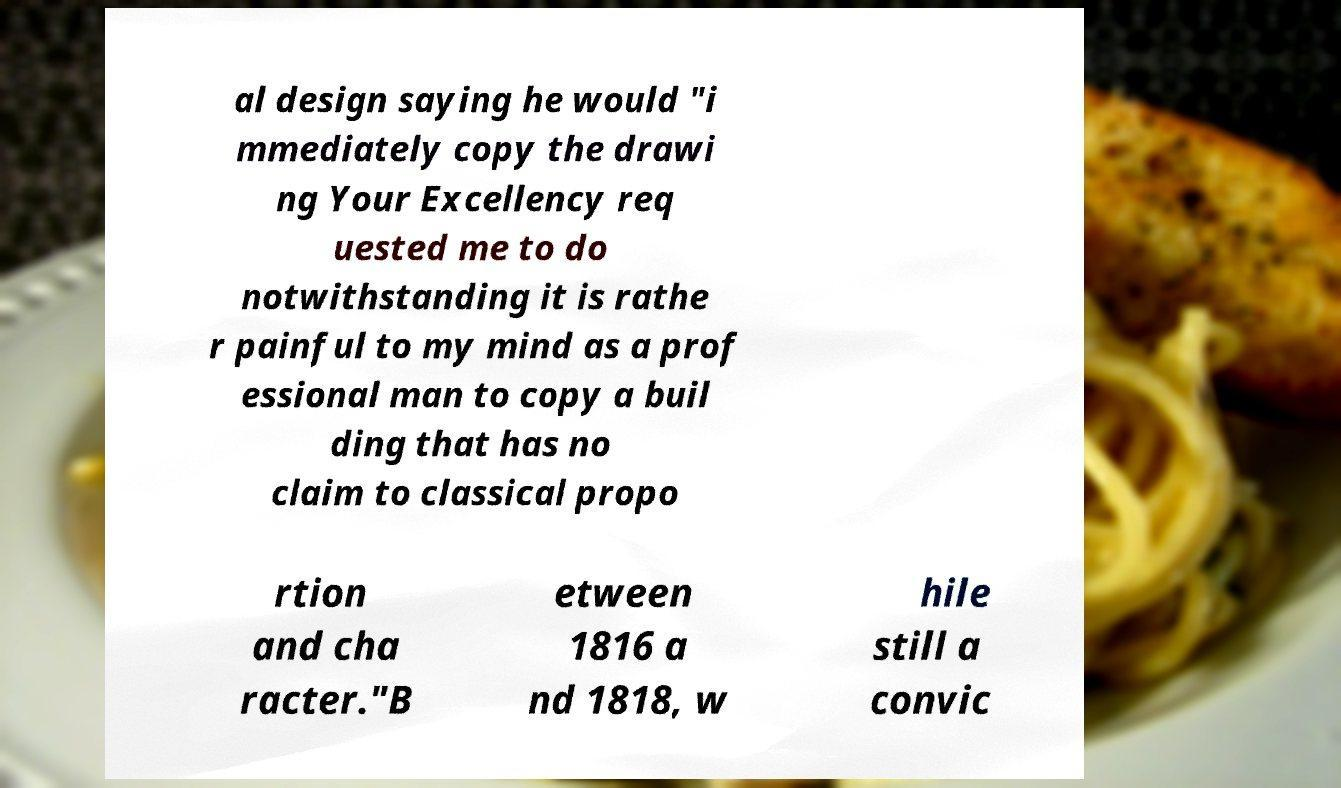Please identify and transcribe the text found in this image. al design saying he would "i mmediately copy the drawi ng Your Excellency req uested me to do notwithstanding it is rathe r painful to my mind as a prof essional man to copy a buil ding that has no claim to classical propo rtion and cha racter."B etween 1816 a nd 1818, w hile still a convic 